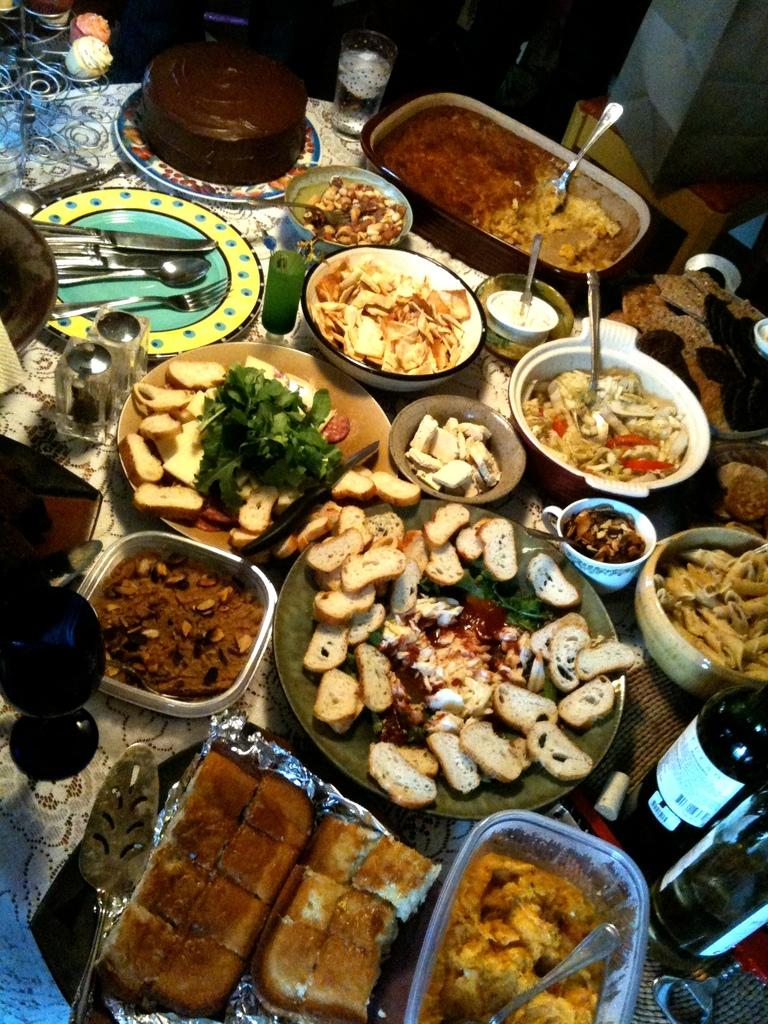What types of objects are in the foreground of the image? There are food items, bottles, and spoons in the foreground of the image. Can you describe the food items in the image? Unfortunately, the specific food items cannot be identified from the provided facts. What might be used to consume the food items in the image? The spoons in the foreground of the image might be used to consume the food items. What type of guide is present in the image? There is no guide present in the image. What color is the vest worn by the person in the image? There is no person or vest present in the image. 